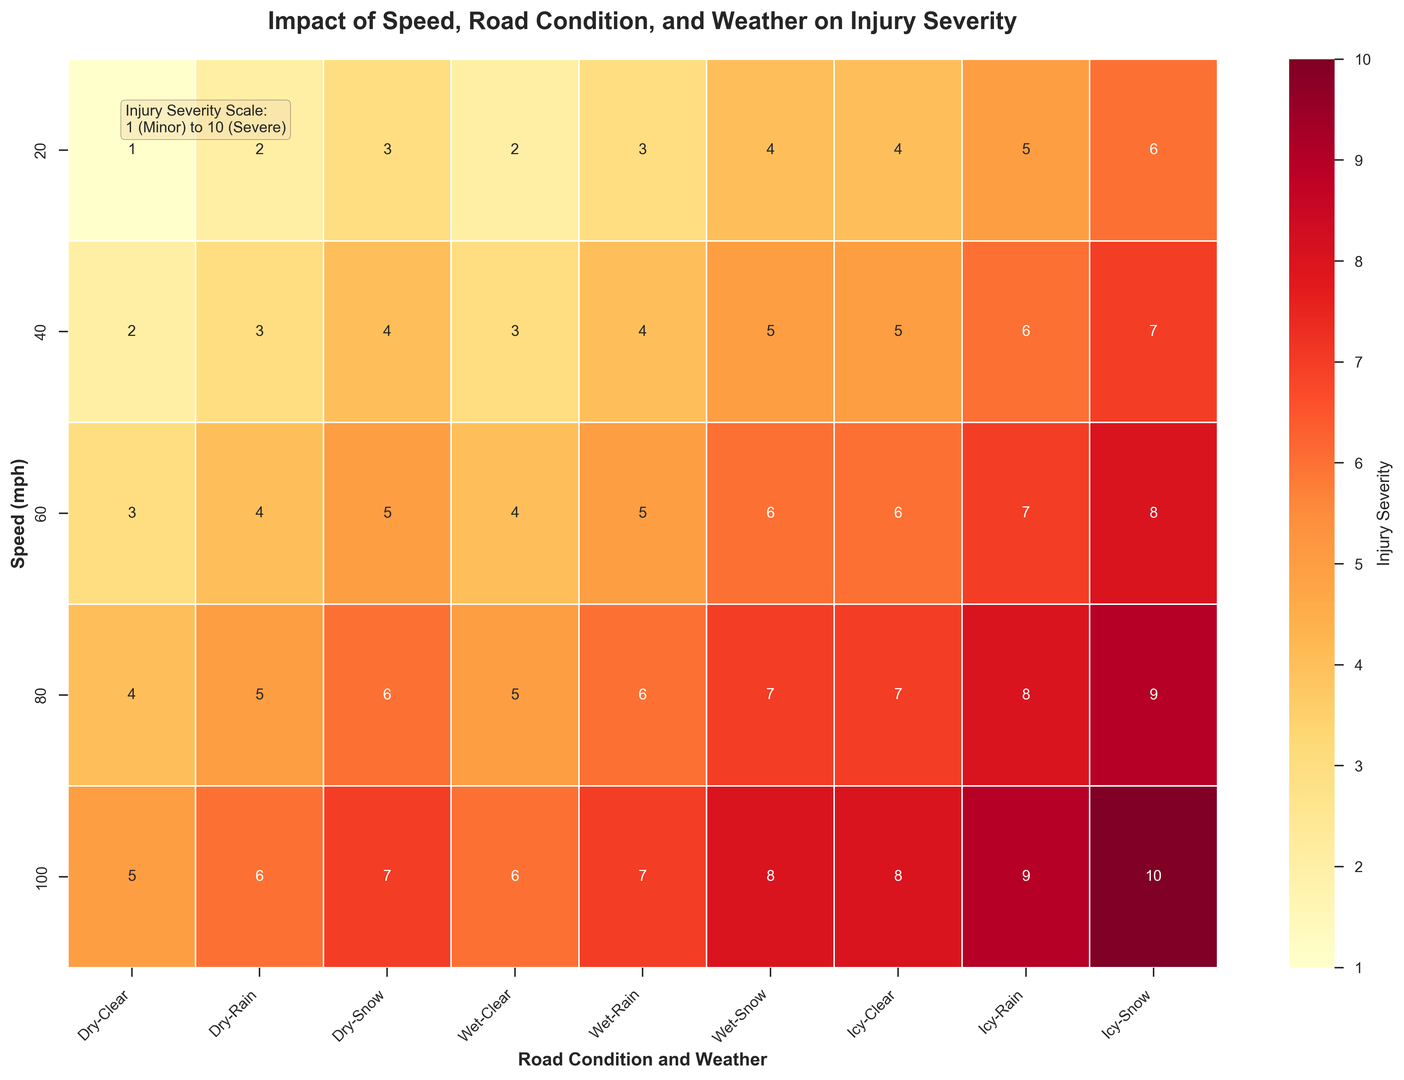What is the injury severity for a vehicle traveling at 60 mph on icy roads during snow? To find the injury severity for a vehicle traveling at 60 mph on icy roads during snow, find the intersection of the row labeled 60 under the Speed (mph) column and the column labeled 'Icy' and 'Snow' under the Road Condition and Weather columns. The value at this intersection is the injury severity.
Answer: 8 What is the difference in injury severity between a speed of 20 mph and 100 mph on wet roads in clear weather? Locate the injury severity for 20 mph and 100 mph on wet roads in clear weather using the corresponding rows and columns. The value for 20 mph is 2, and for 100 mph is 6. Calculate the difference: 6 - 2 = 4.
Answer: 4 Which weather condition at 40 mph causes more severe injuries: rain on wet roads or snow on dry roads? Identify the injury severity for 40 mph under 'Wet' roads with 'Rain' and under 'Dry' roads with 'Snow'. The values are 4 and 4, respectively. Since both values are the same, neither condition causes more severe injuries.
Answer: Equal What is the injury severity difference between wet and icy road conditions at 80 mph during clear weather? Look at the values for 80 mph under 'Wet' and 'Icy' road conditions during clear weather. The values are 5 and 7, respectively. Calculate the difference: 7 - 5 = 2.
Answer: 2 What is the average injury severity for speeds of 20 mph across all road conditions in snow? Find the values for 20 mph under Snow weather across all road conditions: Dry (3), Wet (4), Icy (6). The average is calculated as (3 + 4 + 6)/3 = 13/3 ≈ 4.33.
Answer: 4.33 At what speed and under what conditions does the injury severity reach 9? Scan the heatmap for 9 under the injury severity scale. It is found at 80 and 100 mph on icy roads in rain.
Answer: 80 and 100 mph, icy roads in rain Compare the injury severity of a vehicle at 40 mph on dry roads in rain and at 60 mph on wet roads in clear weather. Which one is higher? For 40 mph on dry roads in rain, the severity is 3. For 60 mph on wet roads in clear weather, the severity is 4. Since 4 is greater than 3, the injury severity is higher at 60 mph on wet roads in clear weather.
Answer: 60 mph on wet roads in clear weather What is the injury severity for a vehicle traveling at the lowest speed in clear weather on icy roads? The lowest speed considered is 20 mph, so look at the value for 20 mph under Icy roads in clear weather. The value is 4.
Answer: 4 